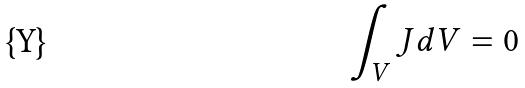<formula> <loc_0><loc_0><loc_500><loc_500>\int _ { V } J d V = 0</formula> 